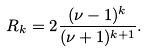<formula> <loc_0><loc_0><loc_500><loc_500>R _ { k } = 2 \frac { ( \nu - 1 ) ^ { k } } { ( \nu + 1 ) ^ { k + 1 } } .</formula> 